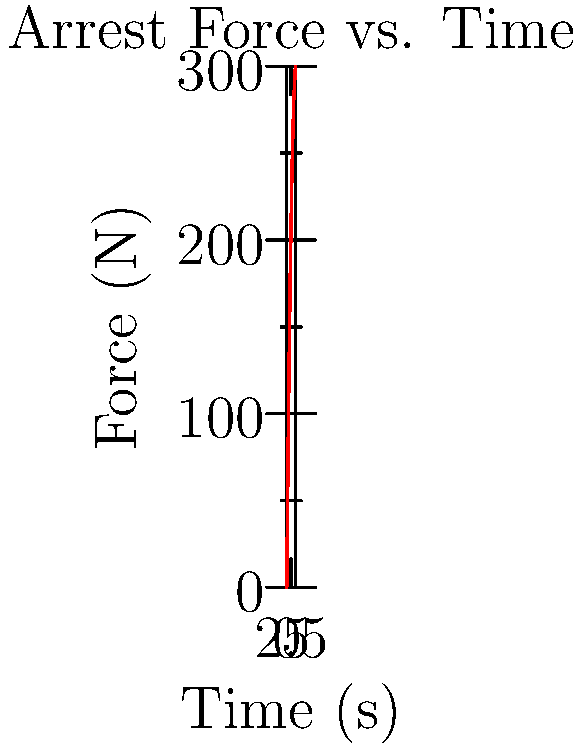During a night shift, you're called to subdue an uncooperative suspect. The graph shows the force applied over time during the arrest. What is the average rate of change of force between 1 and 3 seconds? To find the average rate of change of force between 1 and 3 seconds:

1. Identify the force at t = 1s and t = 3s:
   At t = 1s, F = 100N
   At t = 3s, F = 240N

2. Calculate the change in force (ΔF):
   ΔF = F(3s) - F(1s) = 240N - 100N = 140N

3. Calculate the change in time (Δt):
   Δt = 3s - 1s = 2s

4. Use the formula for average rate of change:
   Average rate of change = ΔF / Δt

5. Substitute the values:
   Average rate of change = 140N / 2s = 70 N/s

Therefore, the average rate of change of force between 1 and 3 seconds is 70 N/s.
Answer: 70 N/s 